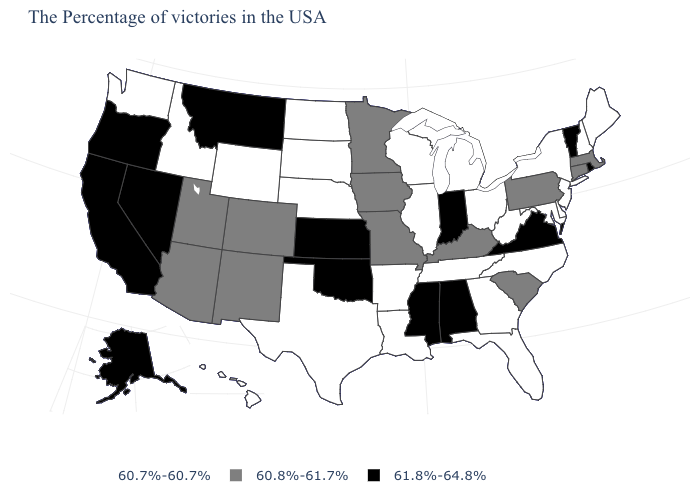Among the states that border Ohio , which have the lowest value?
Concise answer only. West Virginia, Michigan. Among the states that border New Jersey , does New York have the lowest value?
Concise answer only. Yes. Which states have the lowest value in the West?
Give a very brief answer. Wyoming, Idaho, Washington, Hawaii. Name the states that have a value in the range 60.7%-60.7%?
Short answer required. Maine, New Hampshire, New York, New Jersey, Delaware, Maryland, North Carolina, West Virginia, Ohio, Florida, Georgia, Michigan, Tennessee, Wisconsin, Illinois, Louisiana, Arkansas, Nebraska, Texas, South Dakota, North Dakota, Wyoming, Idaho, Washington, Hawaii. What is the value of Colorado?
Write a very short answer. 60.8%-61.7%. Does Tennessee have a higher value than Indiana?
Short answer required. No. Name the states that have a value in the range 60.8%-61.7%?
Be succinct. Massachusetts, Connecticut, Pennsylvania, South Carolina, Kentucky, Missouri, Minnesota, Iowa, Colorado, New Mexico, Utah, Arizona. What is the highest value in the USA?
Keep it brief. 61.8%-64.8%. Which states have the lowest value in the USA?
Write a very short answer. Maine, New Hampshire, New York, New Jersey, Delaware, Maryland, North Carolina, West Virginia, Ohio, Florida, Georgia, Michigan, Tennessee, Wisconsin, Illinois, Louisiana, Arkansas, Nebraska, Texas, South Dakota, North Dakota, Wyoming, Idaho, Washington, Hawaii. Does Nevada have a higher value than Kansas?
Answer briefly. No. Does Colorado have the highest value in the USA?
Write a very short answer. No. Does Wisconsin have the lowest value in the MidWest?
Be succinct. Yes. Name the states that have a value in the range 61.8%-64.8%?
Give a very brief answer. Rhode Island, Vermont, Virginia, Indiana, Alabama, Mississippi, Kansas, Oklahoma, Montana, Nevada, California, Oregon, Alaska. What is the highest value in the USA?
Give a very brief answer. 61.8%-64.8%. What is the value of Nebraska?
Quick response, please. 60.7%-60.7%. 